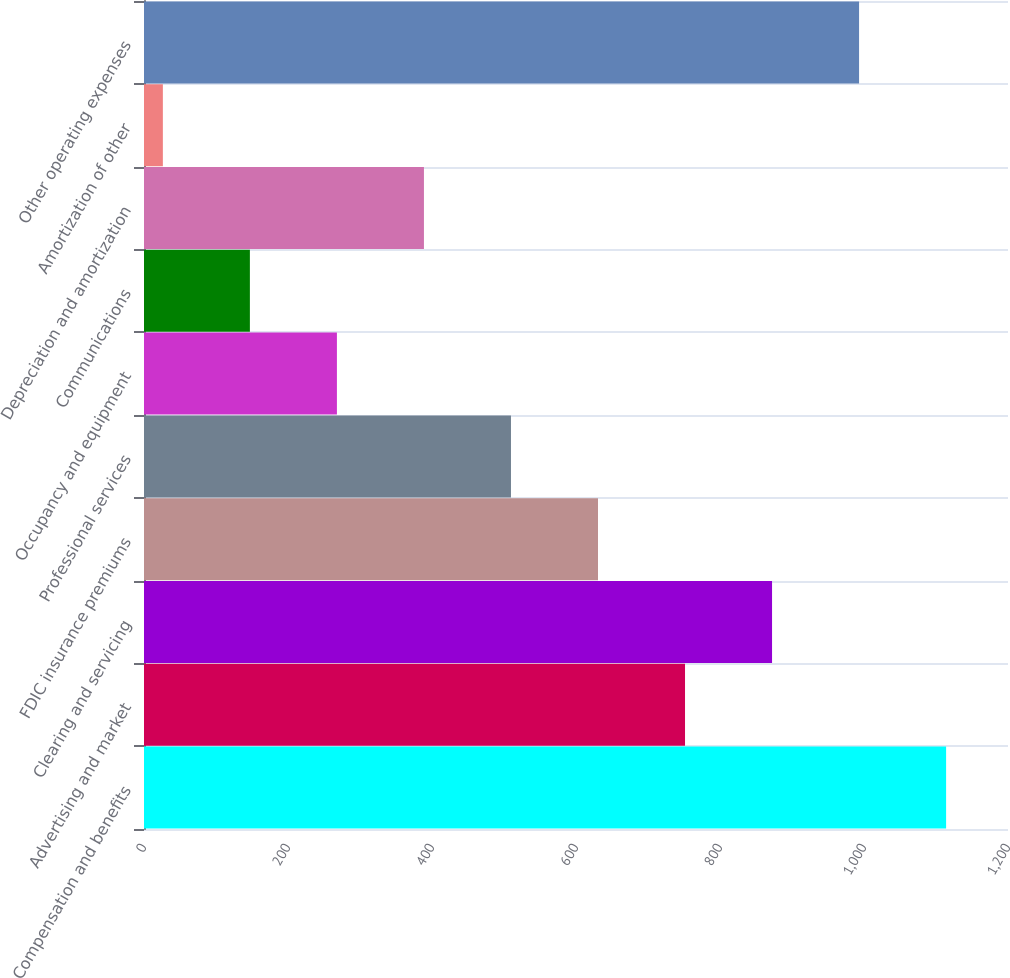Convert chart to OTSL. <chart><loc_0><loc_0><loc_500><loc_500><bar_chart><fcel>Compensation and benefits<fcel>Advertising and market<fcel>Clearing and servicing<fcel>FDIC insurance premiums<fcel>Professional services<fcel>Occupancy and equipment<fcel>Communications<fcel>Depreciation and amortization<fcel>Amortization of other<fcel>Other operating expenses<nl><fcel>1114.03<fcel>751.42<fcel>872.29<fcel>630.55<fcel>509.68<fcel>267.94<fcel>147.07<fcel>388.81<fcel>26.2<fcel>993.16<nl></chart> 